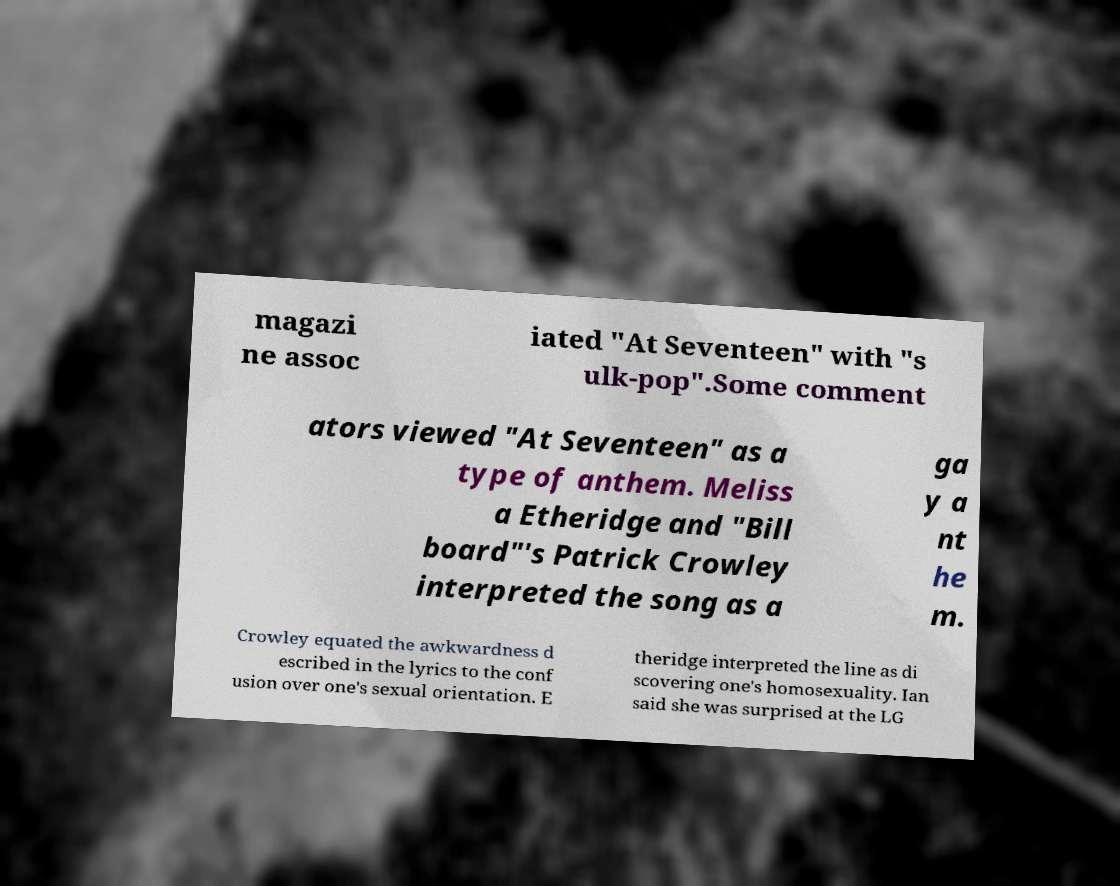Please identify and transcribe the text found in this image. magazi ne assoc iated "At Seventeen" with "s ulk-pop".Some comment ators viewed "At Seventeen" as a type of anthem. Meliss a Etheridge and "Bill board"'s Patrick Crowley interpreted the song as a ga y a nt he m. Crowley equated the awkwardness d escribed in the lyrics to the conf usion over one's sexual orientation. E theridge interpreted the line as di scovering one's homosexuality. Ian said she was surprised at the LG 